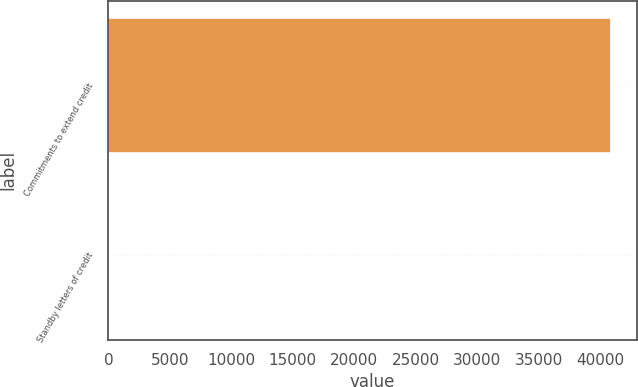Convert chart to OTSL. <chart><loc_0><loc_0><loc_500><loc_500><bar_chart><fcel>Commitments to extend credit<fcel>Standby letters of credit<nl><fcel>40934<fcel>37<nl></chart> 